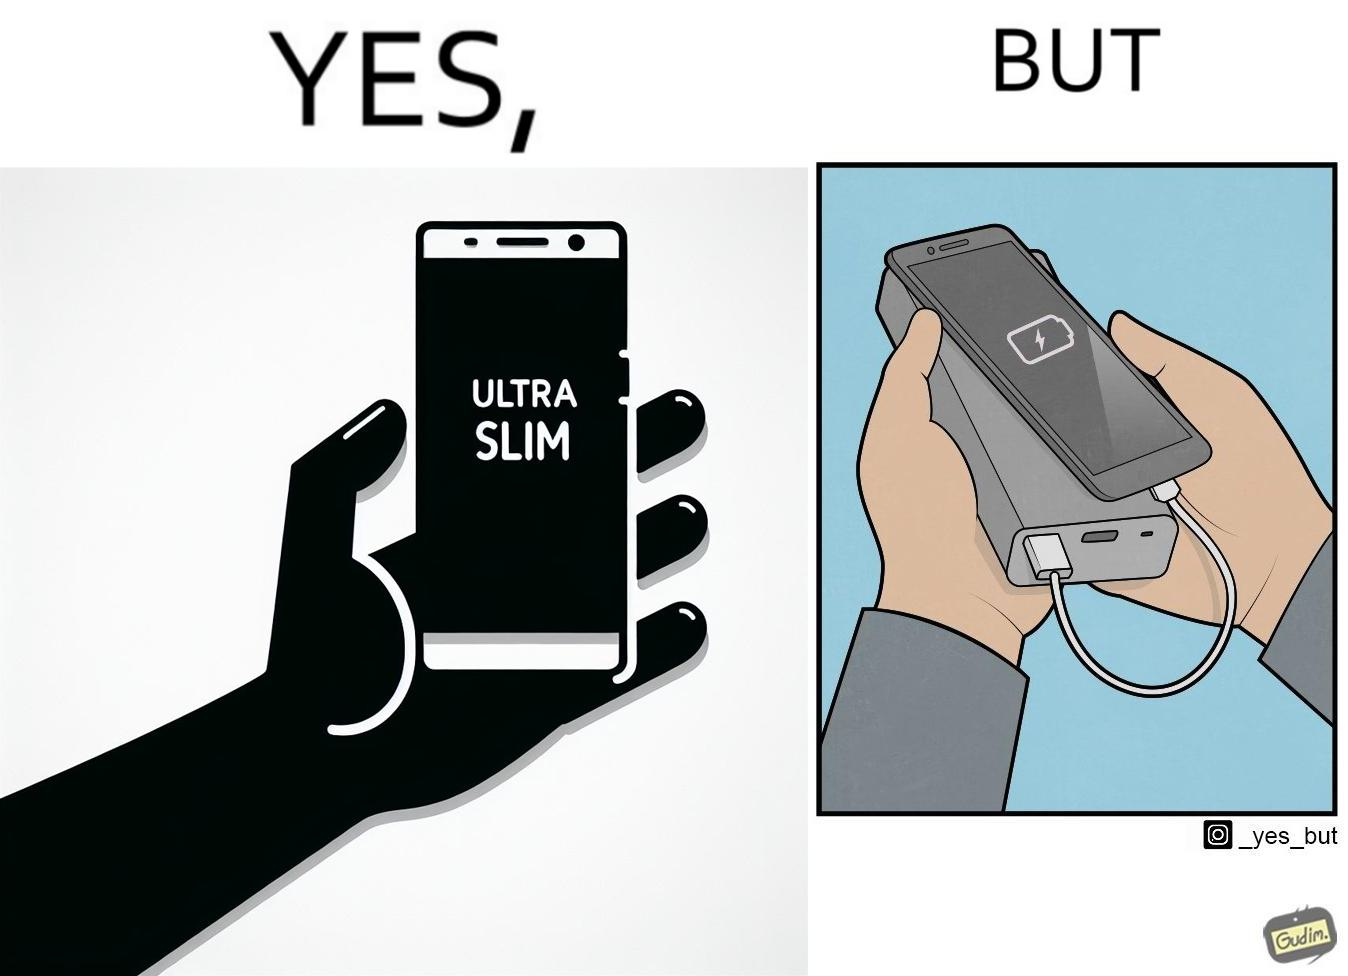Is this a satirical image? Yes, this image is satirical. 